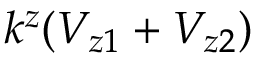<formula> <loc_0><loc_0><loc_500><loc_500>k ^ { z } ( V _ { z 1 } + V _ { z 2 } )</formula> 